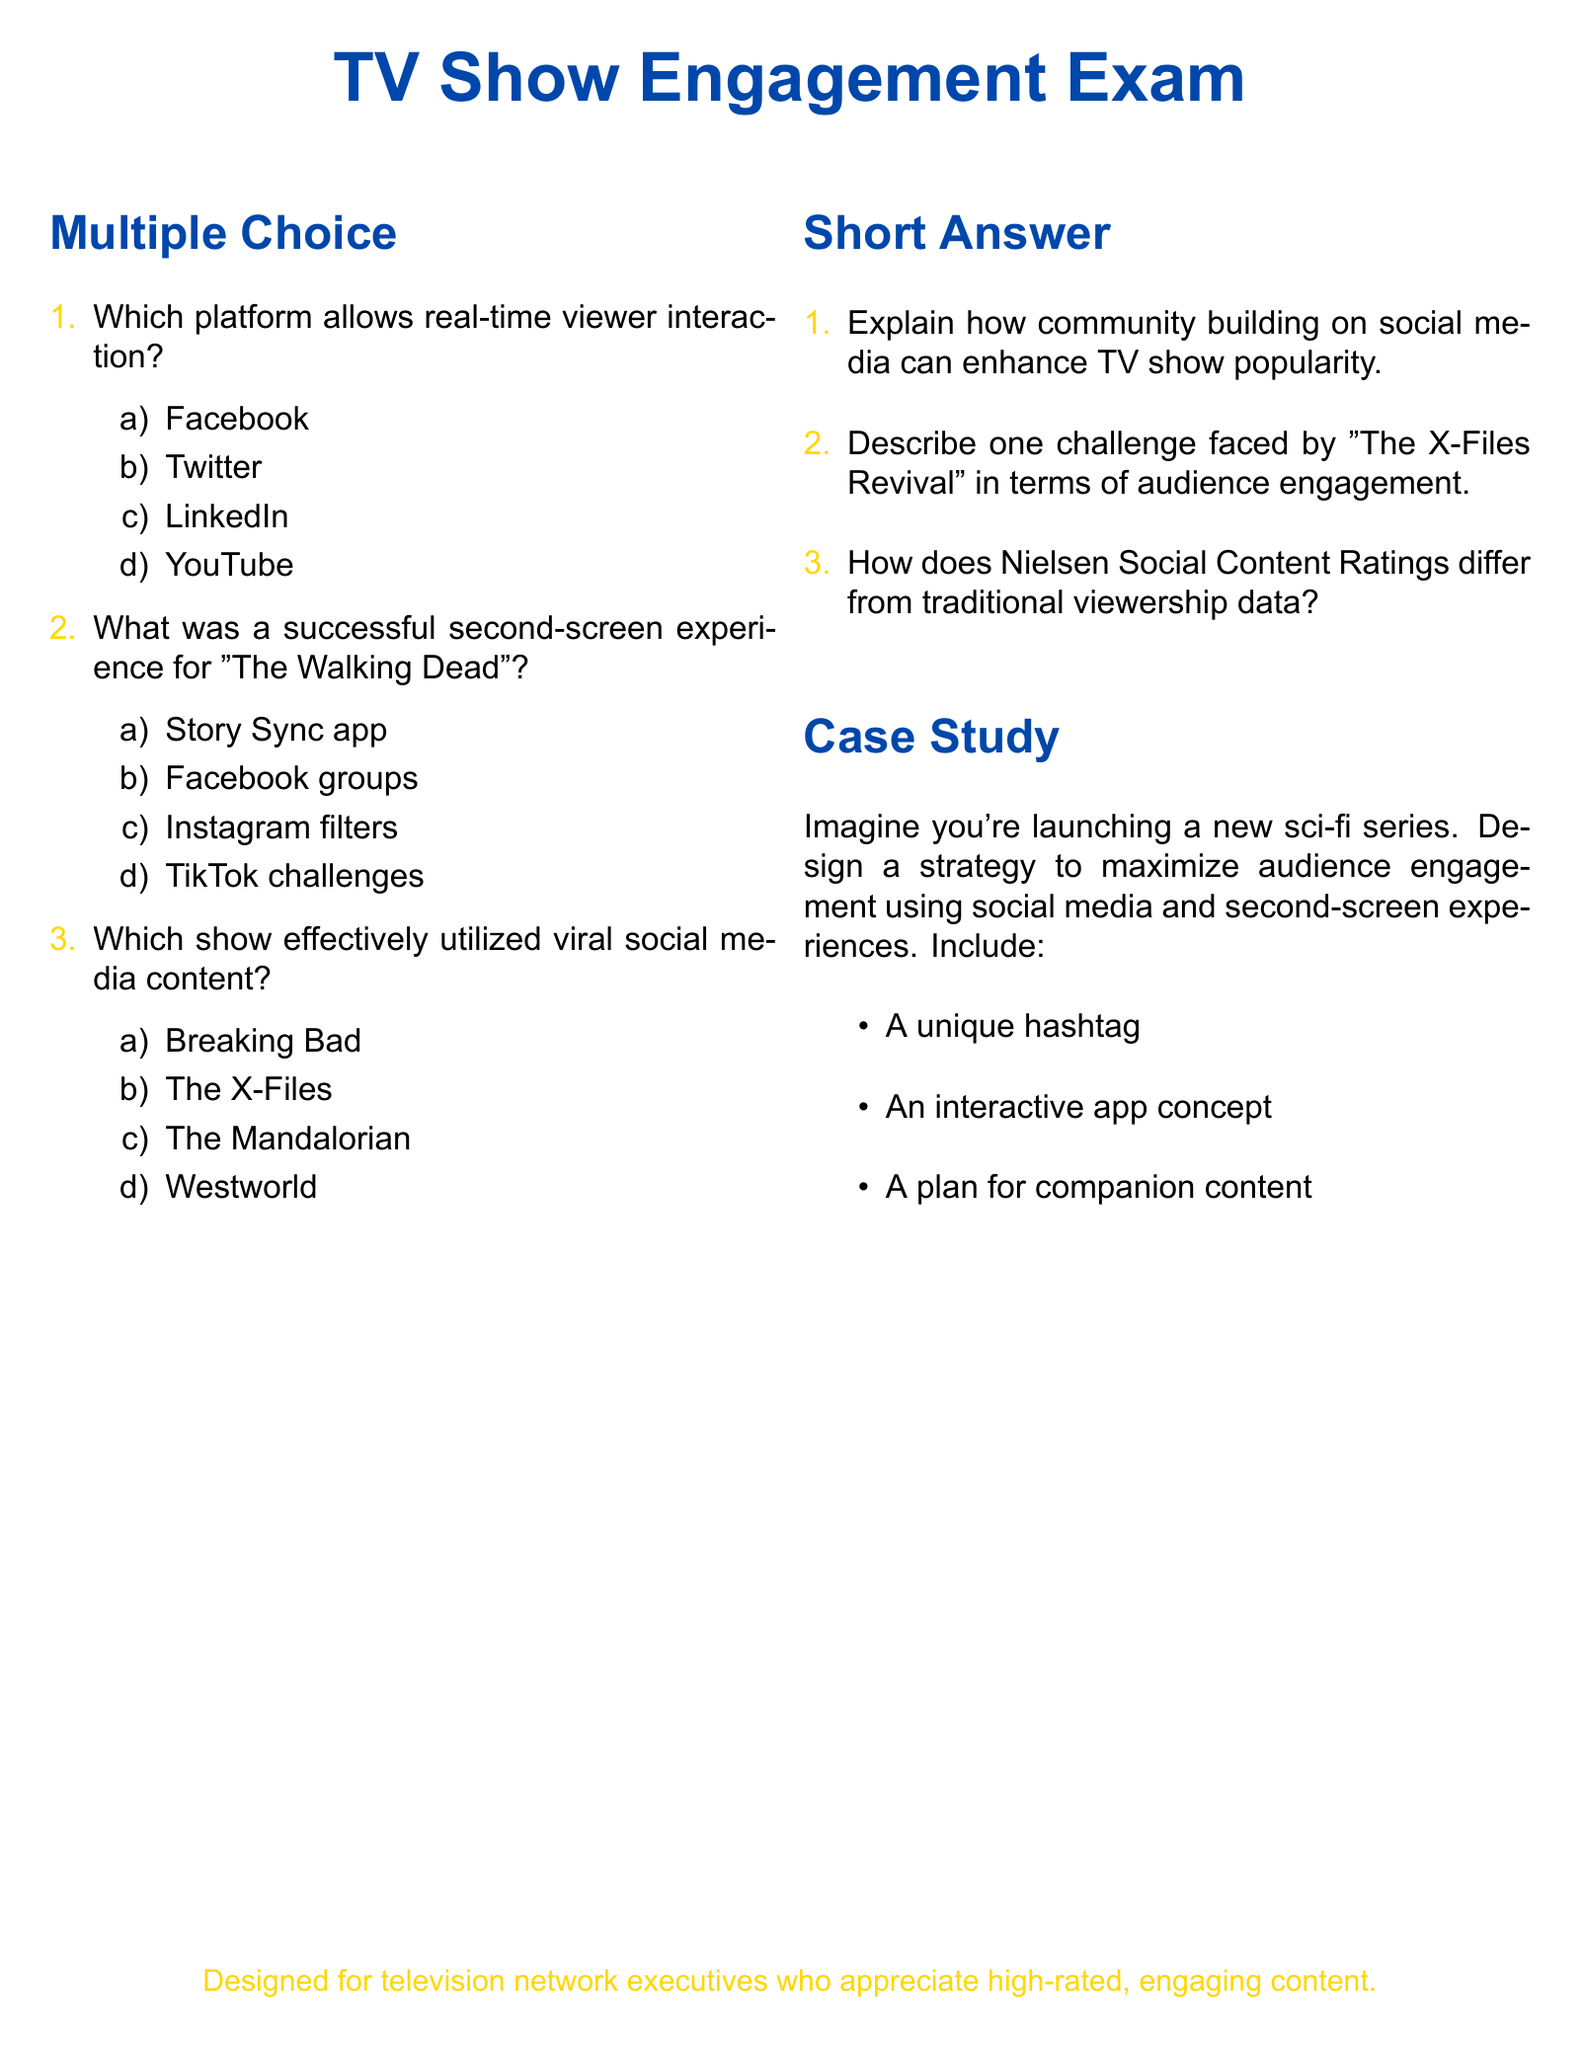What platform allows real-time viewer interaction? The document lists one of the options in the multiple-choice section regarding a platform that enables real-time viewer interaction.
Answer: Twitter What was a successful second-screen experience for "The Walking Dead"? This question draws from the multiple-choice section that references second-screen experiences for the show.
Answer: Story Sync app Which show effectively utilized viral social media content? The document mentions shows and their social media strategies in the multiple-choice section, specifying one that was effective.
Answer: The Mandalorian Explain one challenge faced by "The X-Files Revival" in terms of audience engagement. This question asks for a brief explanation of a specific challenge discussed in the short answer section of the document.
Answer: Not specified How does Nielsen Social Content Ratings differ from traditional viewership data? This requires an understanding of the distinction mentioned in the short answer section.
Answer: Not specified What is a unique hashtag? This refers to the requirement in the case study for a strategy to maximize audience engagement and implies listing a specific example.
Answer: Not specified What is the intended audience of the exam? The document concludes with a note on the design intention which specifies the target audience for the exam.
Answer: television network executives What type of content should be included in the companion content plan? This involves the requirement in the case study to describe components related to engaging audiences.
Answer: Not specified 